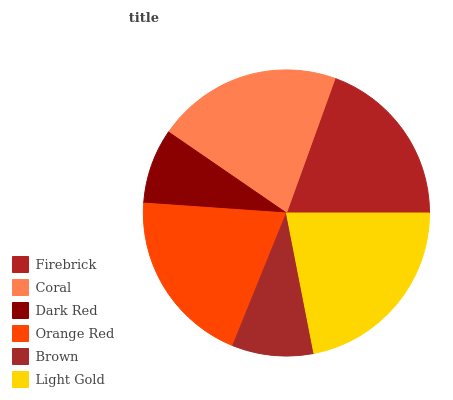Is Dark Red the minimum?
Answer yes or no. Yes. Is Light Gold the maximum?
Answer yes or no. Yes. Is Coral the minimum?
Answer yes or no. No. Is Coral the maximum?
Answer yes or no. No. Is Coral greater than Firebrick?
Answer yes or no. Yes. Is Firebrick less than Coral?
Answer yes or no. Yes. Is Firebrick greater than Coral?
Answer yes or no. No. Is Coral less than Firebrick?
Answer yes or no. No. Is Orange Red the high median?
Answer yes or no. Yes. Is Firebrick the low median?
Answer yes or no. Yes. Is Firebrick the high median?
Answer yes or no. No. Is Brown the low median?
Answer yes or no. No. 